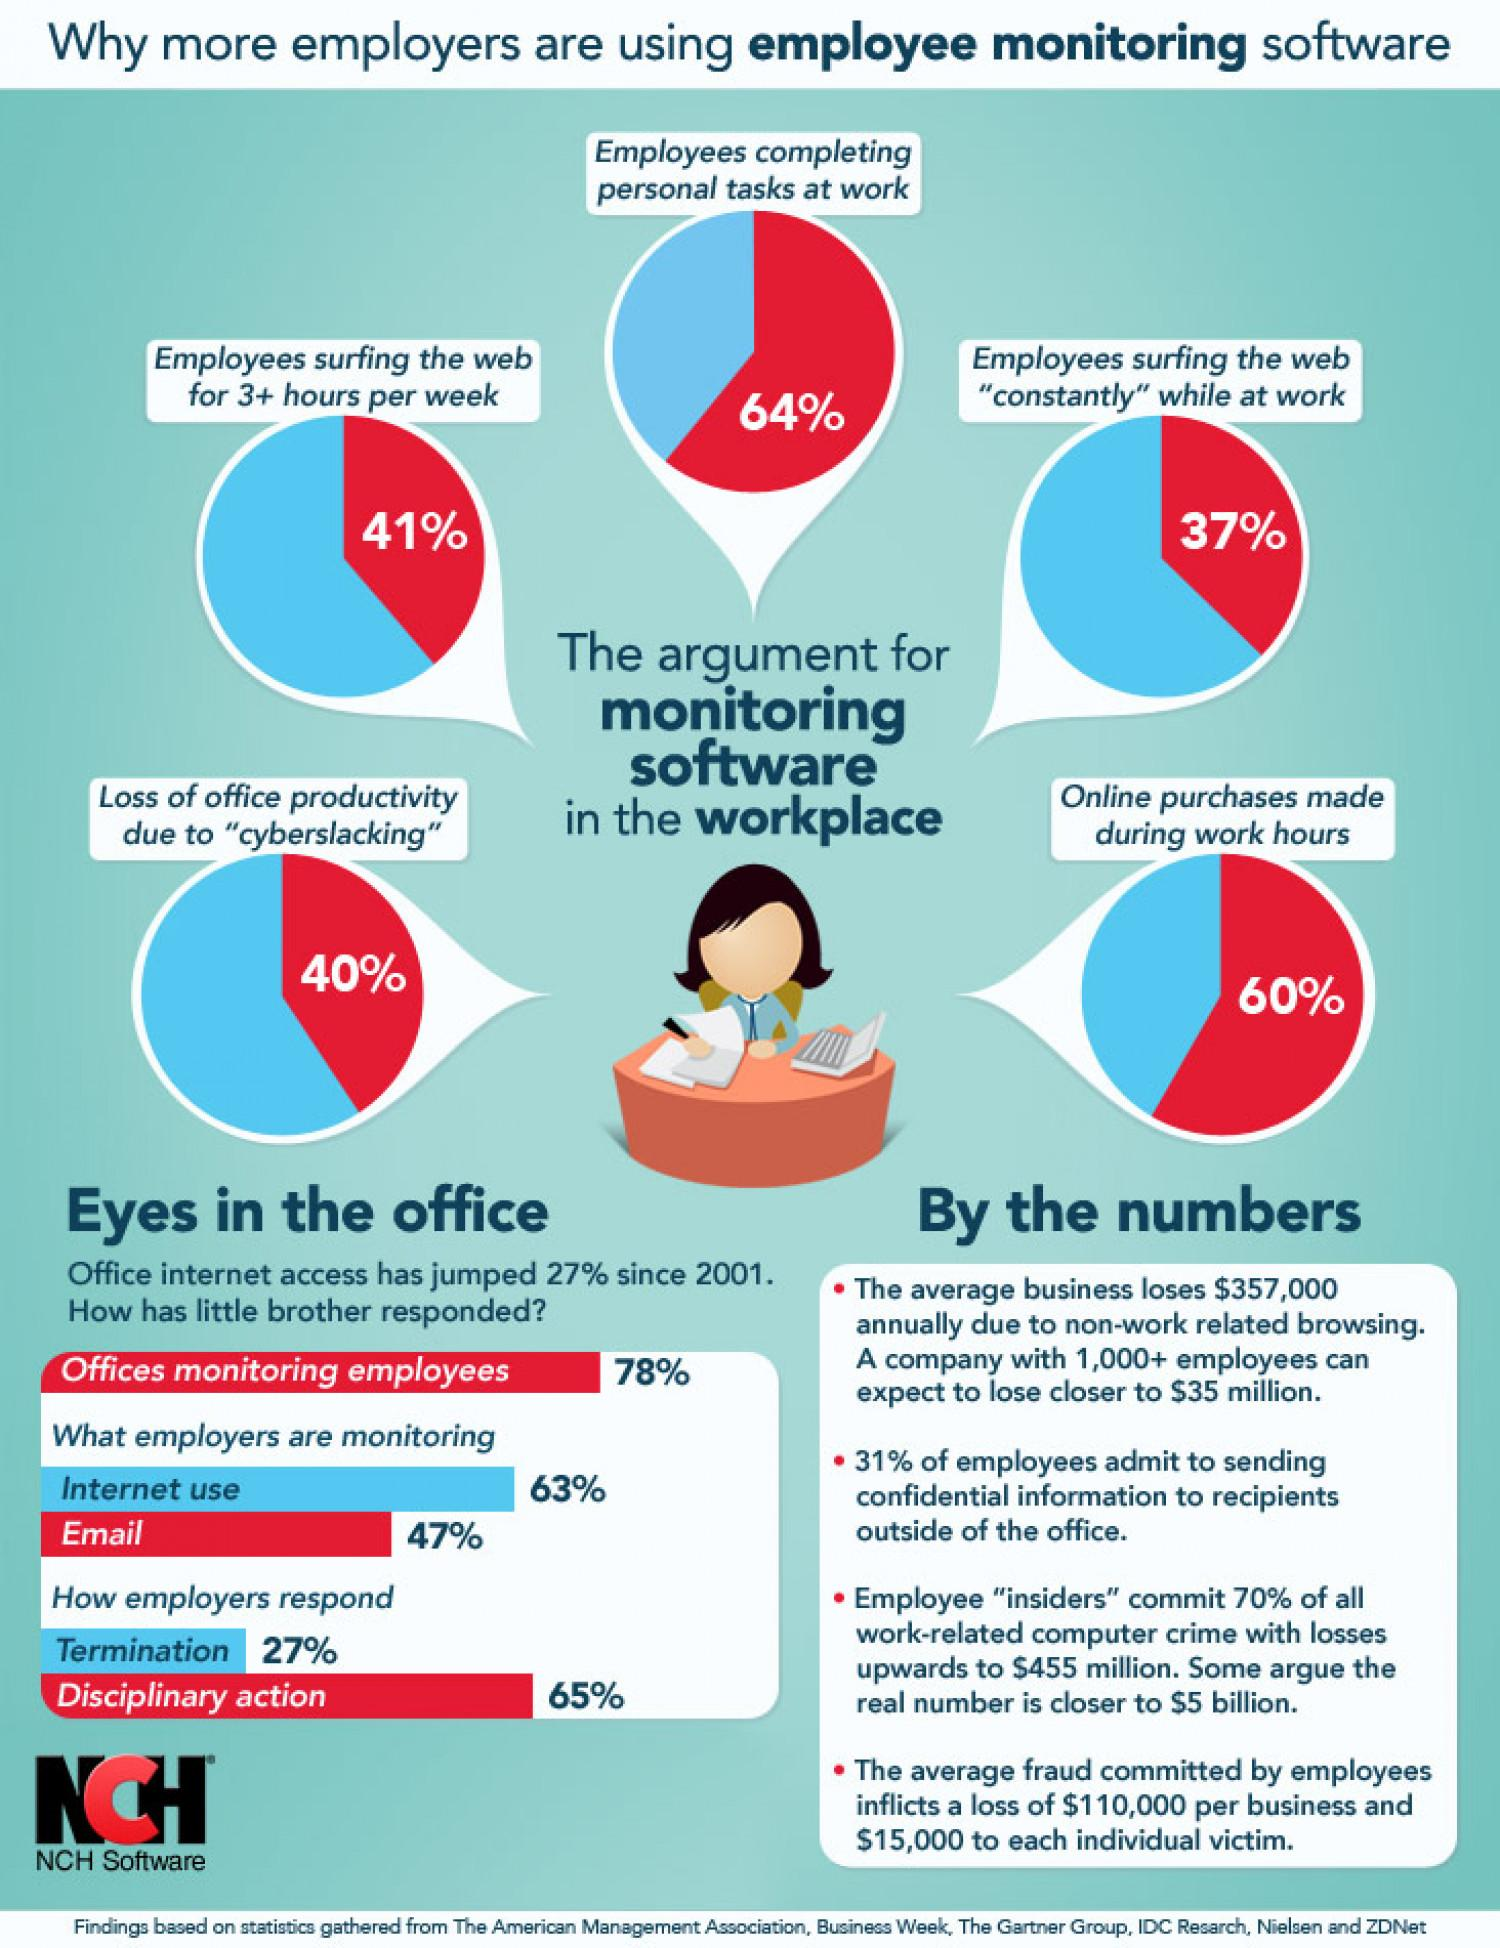List a handful of essential elements in this visual. Approximately 40% of employees do not make online purchases during work hours. In the event that employers discover internet use during work hours, the most common course of action taken is disciplinary action. 